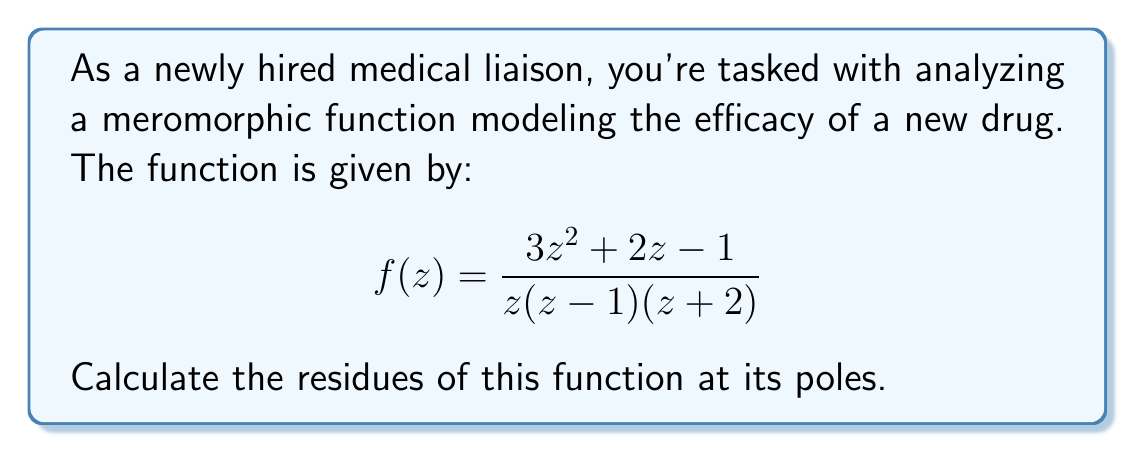Teach me how to tackle this problem. To calculate the residues of the meromorphic function, we need to follow these steps:

1) First, identify the poles of the function. The poles are at $z = 0$, $z = 1$, and $z = -2$.

2) For each pole, we'll calculate the residue using the formula for simple poles:
   
   $\text{Res}(f, a) = \lim_{z \to a} (z-a)f(z)$

3) For $z = 0$:
   $$\text{Res}(f, 0) = \lim_{z \to 0} z \cdot \frac{3z^2 + 2z - 1}{z(z-1)(z+2)} = \lim_{z \to 0} \frac{3z^2 + 2z - 1}{(z-1)(z+2)} = \frac{-1}{(-1)(2)} = \frac{1}{2}$$

4) For $z = 1$:
   $$\text{Res}(f, 1) = \lim_{z \to 1} (z-1) \cdot \frac{3z^2 + 2z - 1}{z(z-1)(z+2)} = \lim_{z \to 1} \frac{3z^2 + 2z - 1}{z(z+2)} = \frac{3(1)^2 + 2(1) - 1}{1(1+2)} = \frac{4}{3}$$

5) For $z = -2$:
   $$\text{Res}(f, -2) = \lim_{z \to -2} (z+2) \cdot \frac{3z^2 + 2z - 1}{z(z-1)(z+2)} = \lim_{z \to -2} \frac{3z^2 + 2z - 1}{z(z-1)} = \frac{3(-2)^2 + 2(-2) - 1}{-2(-3)} = \frac{7}{6}$$

These residues provide crucial information about the behavior of the drug efficacy model near its singular points.
Answer: $\text{Res}(f, 0) = \frac{1}{2}$, $\text{Res}(f, 1) = \frac{4}{3}$, $\text{Res}(f, -2) = \frac{7}{6}$ 